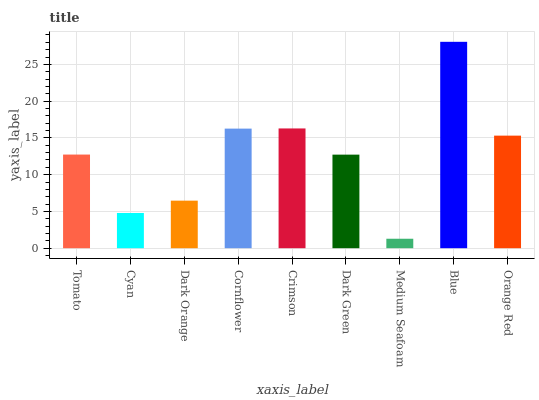Is Medium Seafoam the minimum?
Answer yes or no. Yes. Is Blue the maximum?
Answer yes or no. Yes. Is Cyan the minimum?
Answer yes or no. No. Is Cyan the maximum?
Answer yes or no. No. Is Tomato greater than Cyan?
Answer yes or no. Yes. Is Cyan less than Tomato?
Answer yes or no. Yes. Is Cyan greater than Tomato?
Answer yes or no. No. Is Tomato less than Cyan?
Answer yes or no. No. Is Tomato the high median?
Answer yes or no. Yes. Is Tomato the low median?
Answer yes or no. Yes. Is Blue the high median?
Answer yes or no. No. Is Blue the low median?
Answer yes or no. No. 